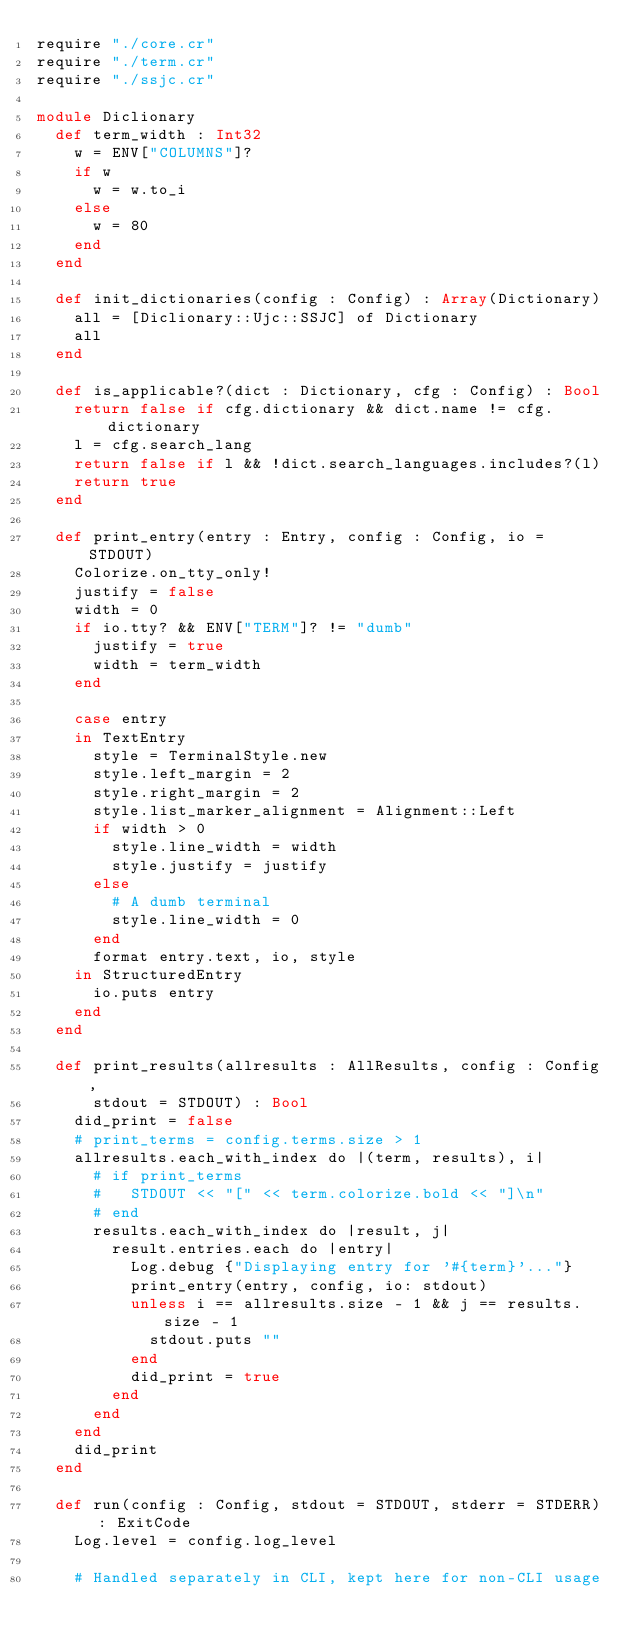Convert code to text. <code><loc_0><loc_0><loc_500><loc_500><_Crystal_>require "./core.cr"
require "./term.cr"
require "./ssjc.cr"

module Diclionary
	def term_width : Int32
		w = ENV["COLUMNS"]?
		if w
			w = w.to_i
		else
			w = 80
		end
	end

	def init_dictionaries(config : Config) : Array(Dictionary)
		all = [Diclionary::Ujc::SSJC] of Dictionary
		all
	end

	def is_applicable?(dict : Dictionary, cfg : Config) : Bool
		return false if cfg.dictionary && dict.name != cfg.dictionary
		l = cfg.search_lang
		return false if l && !dict.search_languages.includes?(l)
		return true
	end

	def print_entry(entry : Entry, config : Config, io = STDOUT)
		Colorize.on_tty_only!
		justify = false
		width = 0
		if io.tty? && ENV["TERM"]? != "dumb"
			justify = true
			width = term_width
		end

		case entry
		in TextEntry
			style = TerminalStyle.new
			style.left_margin = 2
			style.right_margin = 2
			style.list_marker_alignment = Alignment::Left
			if width > 0
				style.line_width = width
				style.justify = justify
			else
				# A dumb terminal
				style.line_width = 0
			end
			format entry.text, io, style
		in StructuredEntry
			io.puts entry
		end
	end

	def print_results(allresults : AllResults, config : Config,
			stdout = STDOUT) : Bool
		did_print = false
		# print_terms = config.terms.size > 1
		allresults.each_with_index do |(term, results), i|
			# if print_terms
			# 	STDOUT << "[" << term.colorize.bold << "]\n"
			# end
			results.each_with_index do |result, j|
				result.entries.each do |entry|
					Log.debug {"Displaying entry for '#{term}'..."}
					print_entry(entry, config, io: stdout)
					unless i == allresults.size - 1 && j == results.size - 1
						stdout.puts ""
					end
					did_print = true
				end
			end
		end
		did_print
	end

	def run(config : Config, stdout = STDOUT, stderr = STDERR) : ExitCode
		Log.level = config.log_level

		# Handled separately in CLI, kept here for non-CLI usage</code> 